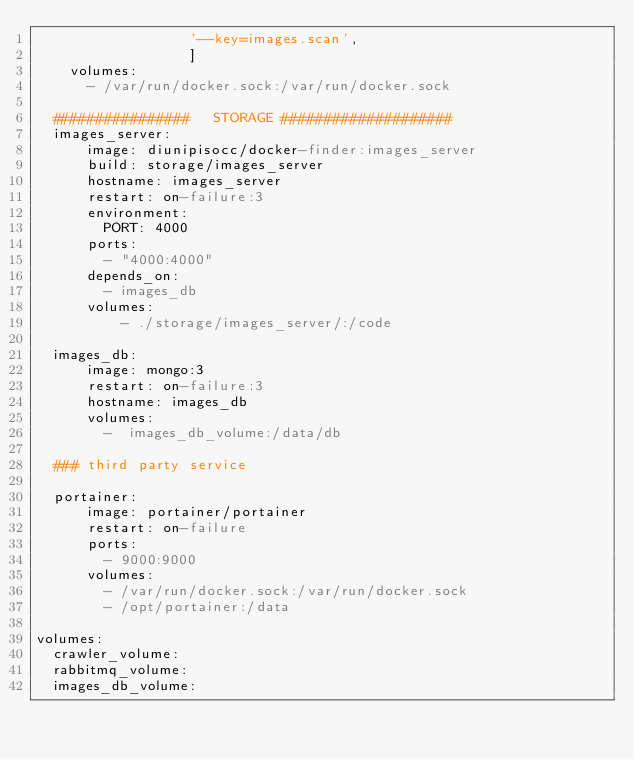Convert code to text. <code><loc_0><loc_0><loc_500><loc_500><_YAML_>                  '--key=images.scan',
                  ]
    volumes:
      - /var/run/docker.sock:/var/run/docker.sock

  ################   STORAGE ####################
  images_server:
      image: diunipisocc/docker-finder:images_server
      build: storage/images_server
      hostname: images_server
      restart: on-failure:3
      environment:
        PORT: 4000
      ports:
        - "4000:4000"
      depends_on:
        - images_db
      volumes:
          - ./storage/images_server/:/code

  images_db:
      image: mongo:3
      restart: on-failure:3
      hostname: images_db
      volumes:
        -  images_db_volume:/data/db

  ### third party service

  portainer:
      image: portainer/portainer
      restart: on-failure
      ports:
        - 9000:9000
      volumes:
        - /var/run/docker.sock:/var/run/docker.sock
        - /opt/portainer:/data

volumes:
  crawler_volume:
  rabbitmq_volume:
  images_db_volume:
</code> 